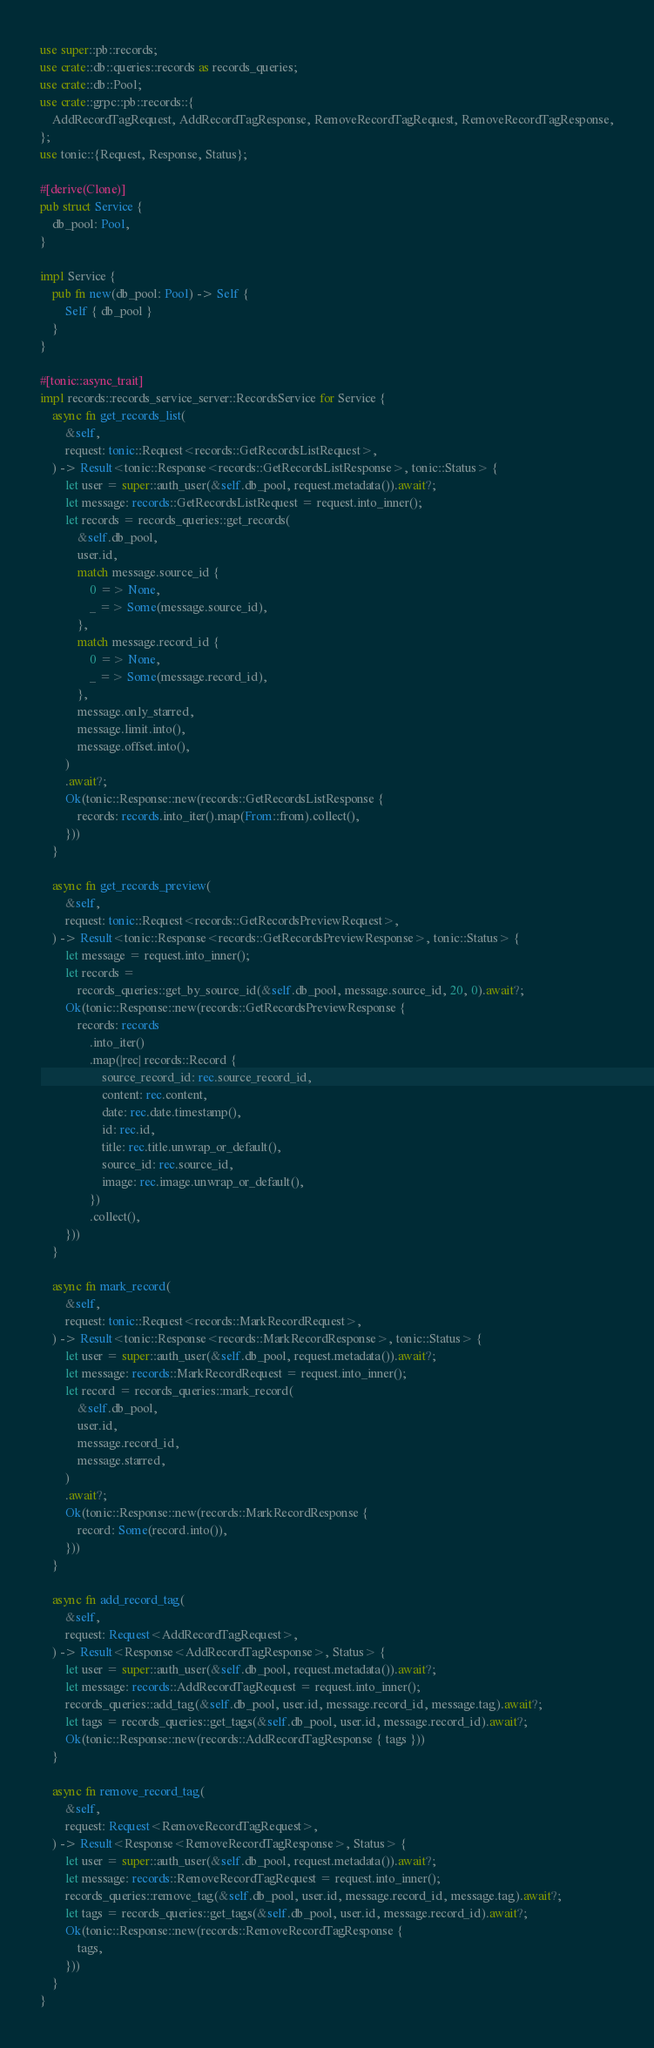<code> <loc_0><loc_0><loc_500><loc_500><_Rust_>use super::pb::records;
use crate::db::queries::records as records_queries;
use crate::db::Pool;
use crate::grpc::pb::records::{
    AddRecordTagRequest, AddRecordTagResponse, RemoveRecordTagRequest, RemoveRecordTagResponse,
};
use tonic::{Request, Response, Status};

#[derive(Clone)]
pub struct Service {
    db_pool: Pool,
}

impl Service {
    pub fn new(db_pool: Pool) -> Self {
        Self { db_pool }
    }
}

#[tonic::async_trait]
impl records::records_service_server::RecordsService for Service {
    async fn get_records_list(
        &self,
        request: tonic::Request<records::GetRecordsListRequest>,
    ) -> Result<tonic::Response<records::GetRecordsListResponse>, tonic::Status> {
        let user = super::auth_user(&self.db_pool, request.metadata()).await?;
        let message: records::GetRecordsListRequest = request.into_inner();
        let records = records_queries::get_records(
            &self.db_pool,
            user.id,
            match message.source_id {
                0 => None,
                _ => Some(message.source_id),
            },
            match message.record_id {
                0 => None,
                _ => Some(message.record_id),
            },
            message.only_starred,
            message.limit.into(),
            message.offset.into(),
        )
        .await?;
        Ok(tonic::Response::new(records::GetRecordsListResponse {
            records: records.into_iter().map(From::from).collect(),
        }))
    }

    async fn get_records_preview(
        &self,
        request: tonic::Request<records::GetRecordsPreviewRequest>,
    ) -> Result<tonic::Response<records::GetRecordsPreviewResponse>, tonic::Status> {
        let message = request.into_inner();
        let records =
            records_queries::get_by_source_id(&self.db_pool, message.source_id, 20, 0).await?;
        Ok(tonic::Response::new(records::GetRecordsPreviewResponse {
            records: records
                .into_iter()
                .map(|rec| records::Record {
                    source_record_id: rec.source_record_id,
                    content: rec.content,
                    date: rec.date.timestamp(),
                    id: rec.id,
                    title: rec.title.unwrap_or_default(),
                    source_id: rec.source_id,
                    image: rec.image.unwrap_or_default(),
                })
                .collect(),
        }))
    }

    async fn mark_record(
        &self,
        request: tonic::Request<records::MarkRecordRequest>,
    ) -> Result<tonic::Response<records::MarkRecordResponse>, tonic::Status> {
        let user = super::auth_user(&self.db_pool, request.metadata()).await?;
        let message: records::MarkRecordRequest = request.into_inner();
        let record = records_queries::mark_record(
            &self.db_pool,
            user.id,
            message.record_id,
            message.starred,
        )
        .await?;
        Ok(tonic::Response::new(records::MarkRecordResponse {
            record: Some(record.into()),
        }))
    }

    async fn add_record_tag(
        &self,
        request: Request<AddRecordTagRequest>,
    ) -> Result<Response<AddRecordTagResponse>, Status> {
        let user = super::auth_user(&self.db_pool, request.metadata()).await?;
        let message: records::AddRecordTagRequest = request.into_inner();
        records_queries::add_tag(&self.db_pool, user.id, message.record_id, message.tag).await?;
        let tags = records_queries::get_tags(&self.db_pool, user.id, message.record_id).await?;
        Ok(tonic::Response::new(records::AddRecordTagResponse { tags }))
    }

    async fn remove_record_tag(
        &self,
        request: Request<RemoveRecordTagRequest>,
    ) -> Result<Response<RemoveRecordTagResponse>, Status> {
        let user = super::auth_user(&self.db_pool, request.metadata()).await?;
        let message: records::RemoveRecordTagRequest = request.into_inner();
        records_queries::remove_tag(&self.db_pool, user.id, message.record_id, message.tag).await?;
        let tags = records_queries::get_tags(&self.db_pool, user.id, message.record_id).await?;
        Ok(tonic::Response::new(records::RemoveRecordTagResponse {
            tags,
        }))
    }
}
</code> 